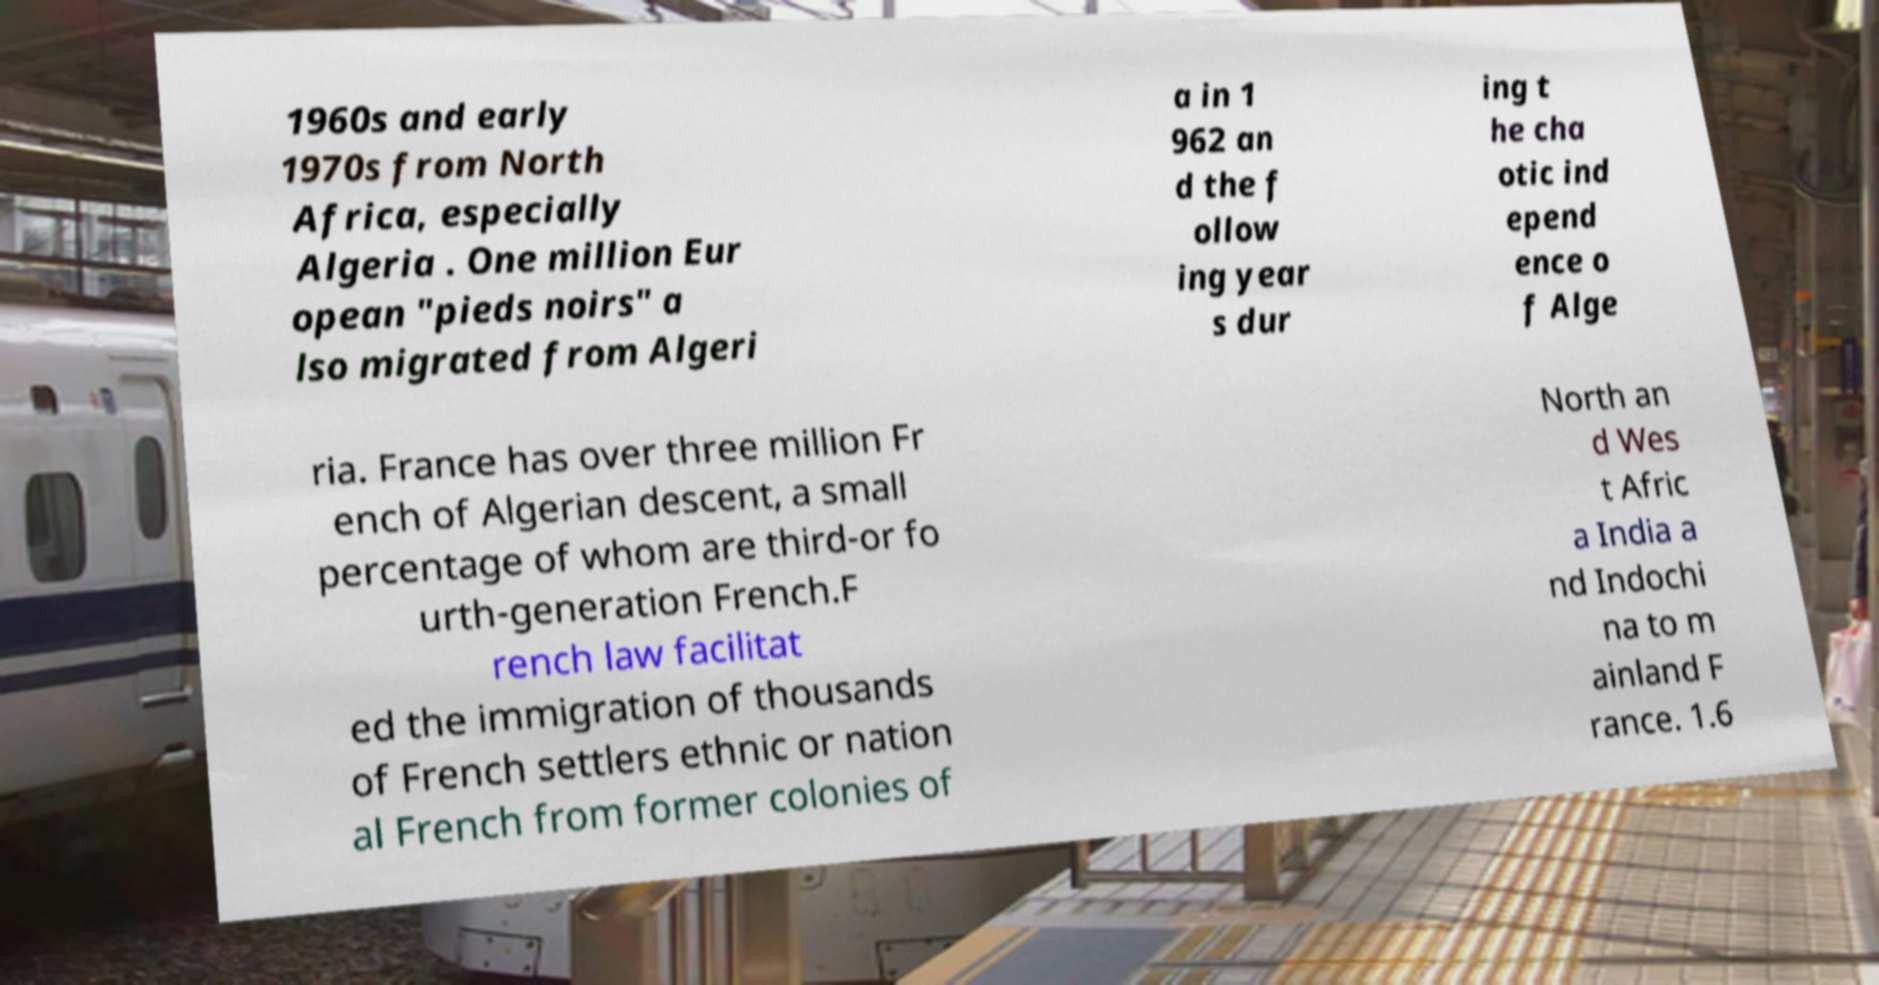Please identify and transcribe the text found in this image. 1960s and early 1970s from North Africa, especially Algeria . One million Eur opean "pieds noirs" a lso migrated from Algeri a in 1 962 an d the f ollow ing year s dur ing t he cha otic ind epend ence o f Alge ria. France has over three million Fr ench of Algerian descent, a small percentage of whom are third-or fo urth-generation French.F rench law facilitat ed the immigration of thousands of French settlers ethnic or nation al French from former colonies of North an d Wes t Afric a India a nd Indochi na to m ainland F rance. 1.6 